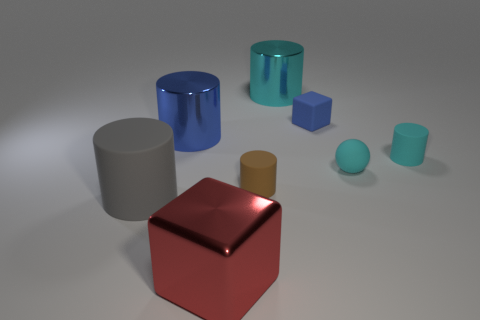Subtract all gray cylinders. How many cylinders are left? 4 Subtract all big matte cylinders. How many cylinders are left? 4 Subtract all yellow cylinders. Subtract all red blocks. How many cylinders are left? 5 Add 2 large yellow metallic cylinders. How many objects exist? 10 Subtract all spheres. How many objects are left? 7 Add 6 tiny blue metal balls. How many tiny blue metal balls exist? 6 Subtract 0 red cylinders. How many objects are left? 8 Subtract all cyan things. Subtract all blue rubber blocks. How many objects are left? 4 Add 8 blue blocks. How many blue blocks are left? 9 